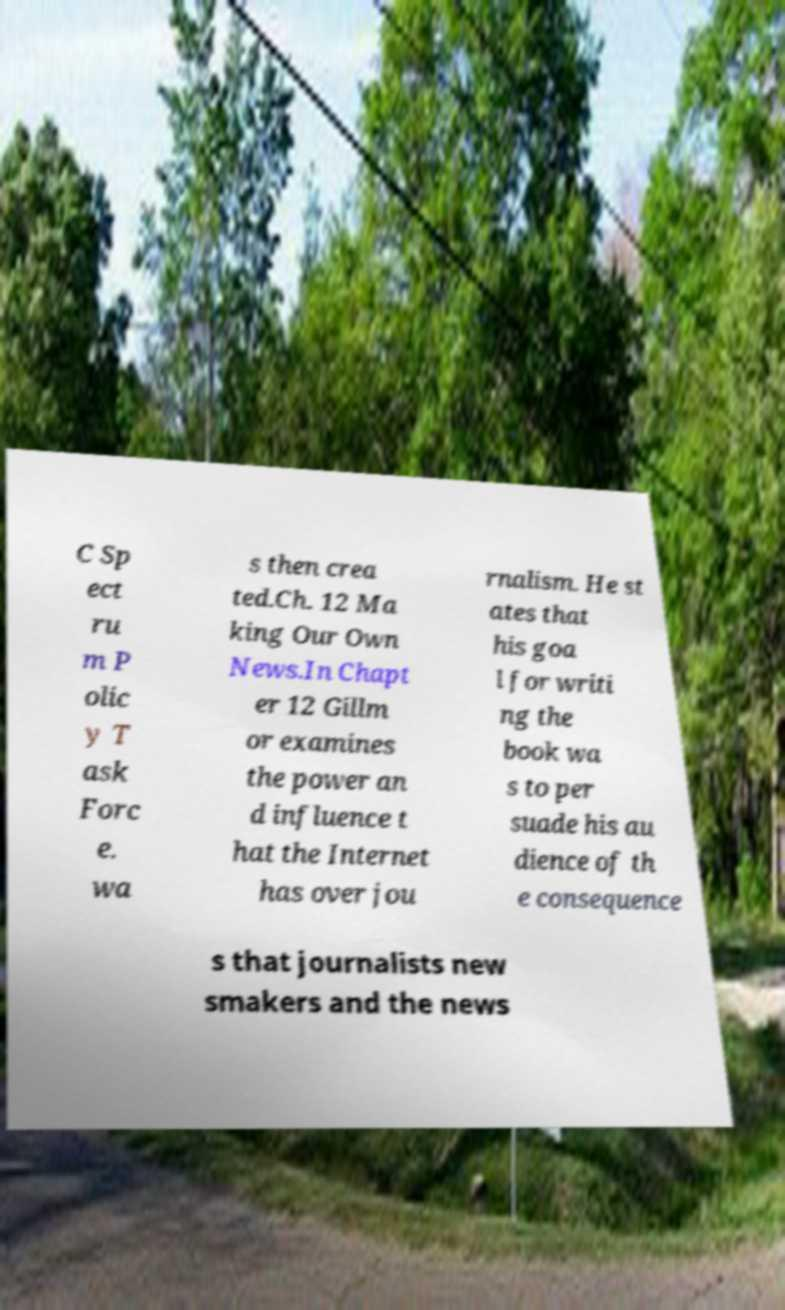There's text embedded in this image that I need extracted. Can you transcribe it verbatim? C Sp ect ru m P olic y T ask Forc e. wa s then crea ted.Ch. 12 Ma king Our Own News.In Chapt er 12 Gillm or examines the power an d influence t hat the Internet has over jou rnalism. He st ates that his goa l for writi ng the book wa s to per suade his au dience of th e consequence s that journalists new smakers and the news 